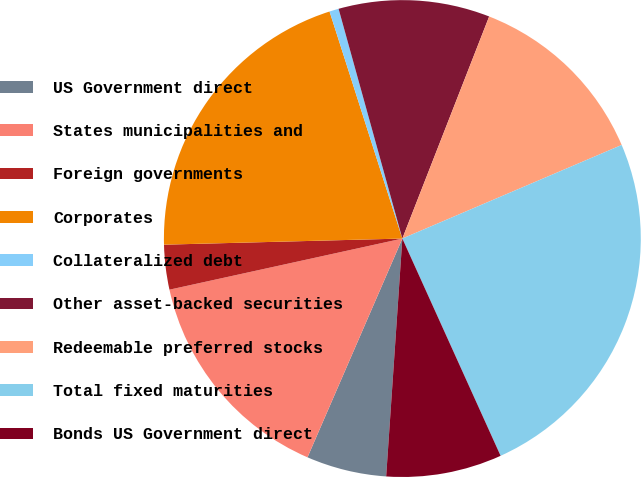Convert chart to OTSL. <chart><loc_0><loc_0><loc_500><loc_500><pie_chart><fcel>US Government direct<fcel>States municipalities and<fcel>Foreign governments<fcel>Corporates<fcel>Collateralized debt<fcel>Other asset-backed securities<fcel>Redeemable preferred stocks<fcel>Total fixed maturities<fcel>Bonds US Government direct<nl><fcel>5.43%<fcel>15.05%<fcel>3.03%<fcel>20.47%<fcel>0.63%<fcel>10.24%<fcel>12.65%<fcel>24.66%<fcel>7.84%<nl></chart> 